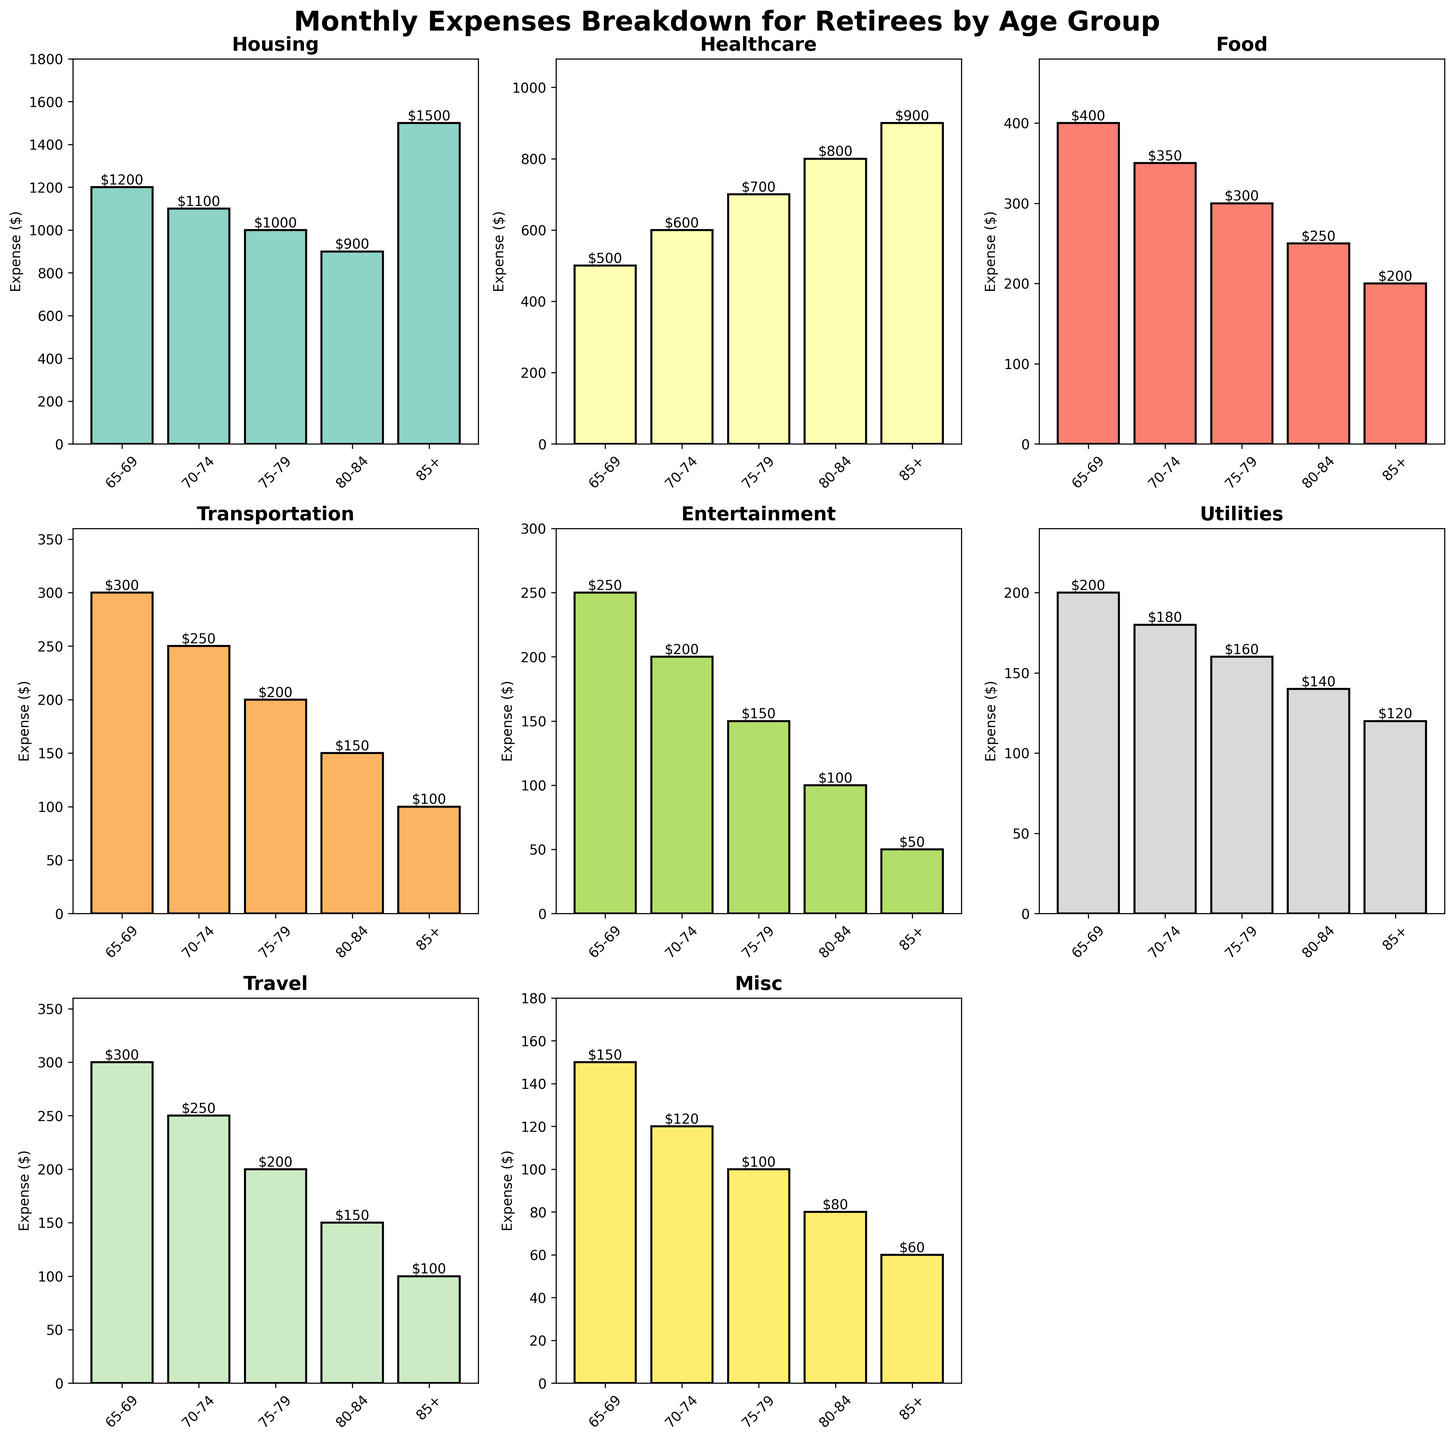Which age group has the highest expense on housing? By looking at the bar heights in the "Housing" subplot, we can see the different expenditures for each age group. The tallest bar corresponds to the 85+ age group.
Answer: 85+ What is the total monthly expense for the 70-74 age group? Add the values for all categories for the 70-74 age group: 1100 (Housing) + 600 (Healthcare) + 350 (Food) + 250 (Transportation) + 200 (Entertainment) + 180 (Utilities) + 250 (Travel) + 120 (Misc) = 3050.
Answer: 3050 Which expense category sees the most significant decrease from the 65-69 age group to the 85+ age group? Compare each category value of the 65-69 and 85+ age groups and find the one with the highest difference: Housing (1200-1500), Healthcare (500-900), Food (400-200), Transportation (300-100), Entertainment (250-50), Utilities (200-120), Travel (300-100), Misc (150-60). Transportation decreases by 200, Housing increases by 300, Healthcare increases by 400, Food decreases by 200, Entertainment decreases by 200, Utilities decrease by 80, and Misc decreases by 90.
Answer: Entertainment What are the two categories where the expense consistently decreases as age increases? Look at each age group in each category to determine if the value consistently decreases: Entertainment (250, 200, 150, 100, 50), Travel (300, 250, 200, 150, 100). These two categories decrease in every plotted age group.
Answer: Entertainment, Travel By how much does the healthcare expense increase from the 65-69 age group to the 85+ age group? Subtract the Healthcare expense for the 65-69 group from that of the 85+ group: 900 (85+) - 500 (65-69) = 400.
Answer: 400 What is the average expense on food across all age groups? Add the food expenses of all age groups and divide by the number of groups: (400 + 350 + 300 + 250 + 200) / 5 = 1500 / 5 = 300.
Answer: 300 